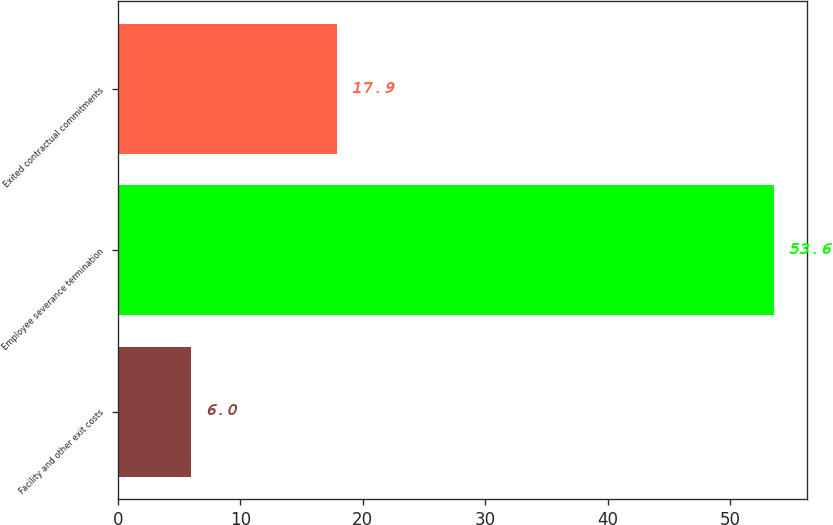Convert chart to OTSL. <chart><loc_0><loc_0><loc_500><loc_500><bar_chart><fcel>Facility and other exit costs<fcel>Employee severance termination<fcel>Exited contractual commitments<nl><fcel>6<fcel>53.6<fcel>17.9<nl></chart> 